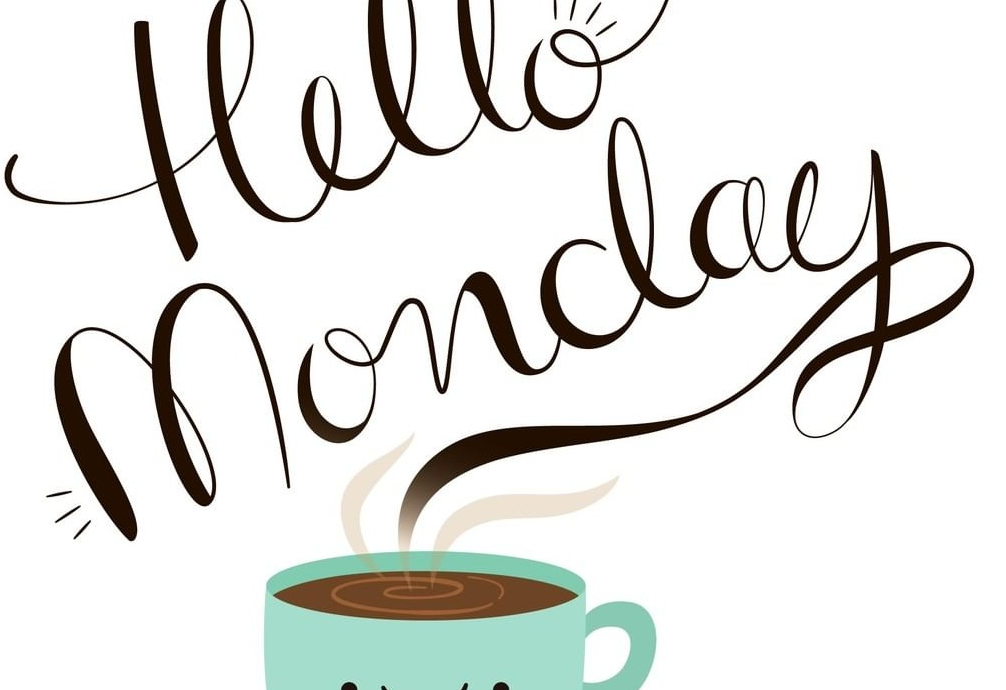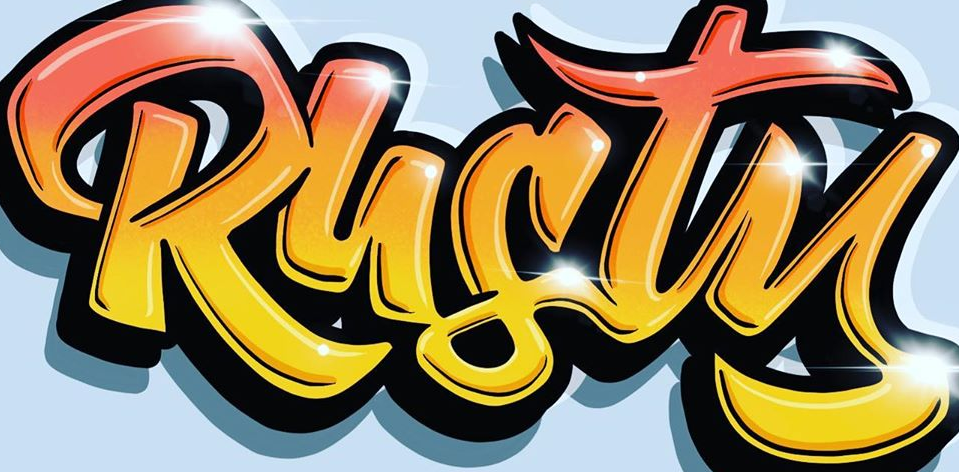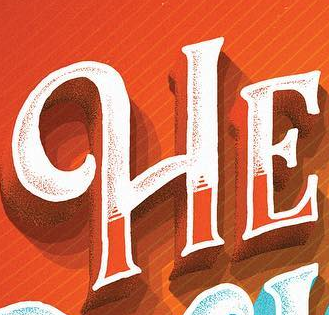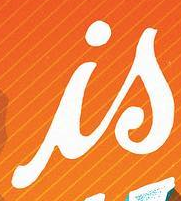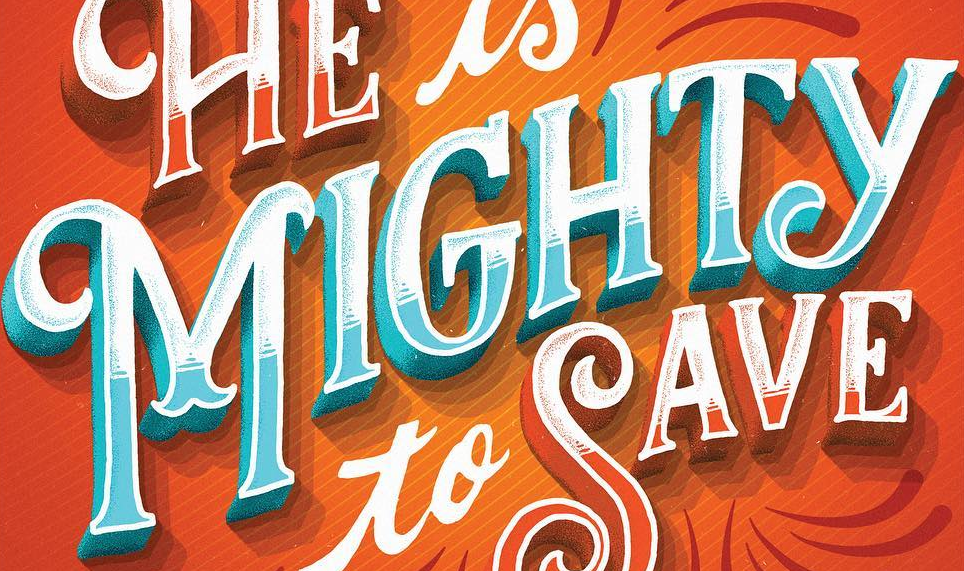Identify the words shown in these images in order, separated by a semicolon. Monday; Rusty; HE; is; MIGHTY 